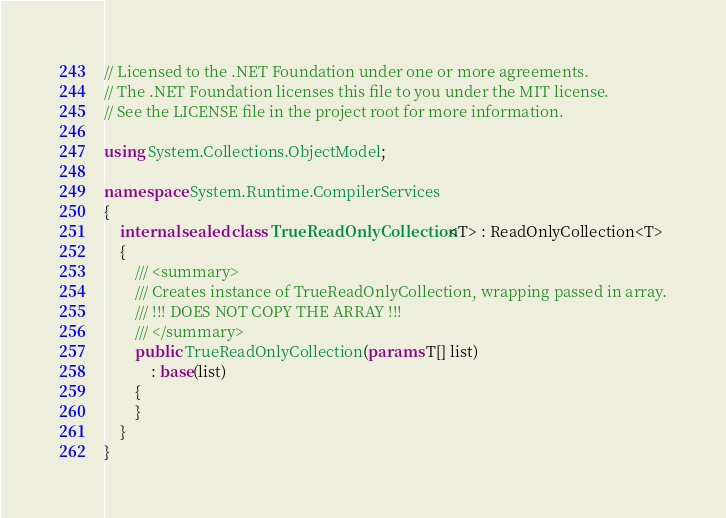Convert code to text. <code><loc_0><loc_0><loc_500><loc_500><_C#_>// Licensed to the .NET Foundation under one or more agreements.
// The .NET Foundation licenses this file to you under the MIT license.
// See the LICENSE file in the project root for more information.

using System.Collections.ObjectModel;

namespace System.Runtime.CompilerServices
{
    internal sealed class TrueReadOnlyCollection<T> : ReadOnlyCollection<T>
    {
        /// <summary>
        /// Creates instance of TrueReadOnlyCollection, wrapping passed in array.
        /// !!! DOES NOT COPY THE ARRAY !!!
        /// </summary>
        public TrueReadOnlyCollection(params T[] list)
            : base(list)
        {
        }
    }
}
</code> 